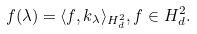Convert formula to latex. <formula><loc_0><loc_0><loc_500><loc_500>f ( \lambda ) = \langle f , k _ { \lambda } \rangle _ { H ^ { 2 } _ { d } } , f \in H ^ { 2 } _ { d } .</formula> 